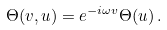Convert formula to latex. <formula><loc_0><loc_0><loc_500><loc_500>\Theta ( v , u ) = e ^ { - i \omega v } \Theta ( u ) \, .</formula> 